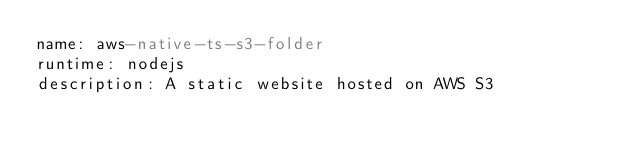<code> <loc_0><loc_0><loc_500><loc_500><_YAML_>name: aws-native-ts-s3-folder
runtime: nodejs
description: A static website hosted on AWS S3
</code> 